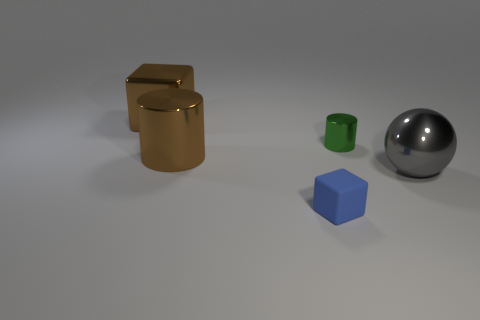Is there any other thing that is made of the same material as the small blue block?
Ensure brevity in your answer.  No. What number of metallic cubes are there?
Make the answer very short. 1. There is a tiny metallic object; is it the same shape as the big brown metal thing that is in front of the green thing?
Your answer should be very brief. Yes. The thing that is the same color as the shiny cube is what size?
Your answer should be very brief. Large. How many things are blue matte blocks or green cylinders?
Provide a succinct answer. 2. The small object behind the brown metal object that is in front of the green shiny thing is what shape?
Your response must be concise. Cylinder. Is the shape of the metallic thing that is behind the green object the same as  the rubber object?
Your answer should be very brief. Yes. What size is the gray ball that is made of the same material as the large cylinder?
Make the answer very short. Large. What number of objects are metal cylinders right of the blue rubber block or metal objects behind the gray sphere?
Offer a very short reply. 3. Are there an equal number of large brown metallic cubes in front of the big metal cylinder and green cylinders that are left of the gray metallic ball?
Keep it short and to the point. No. 